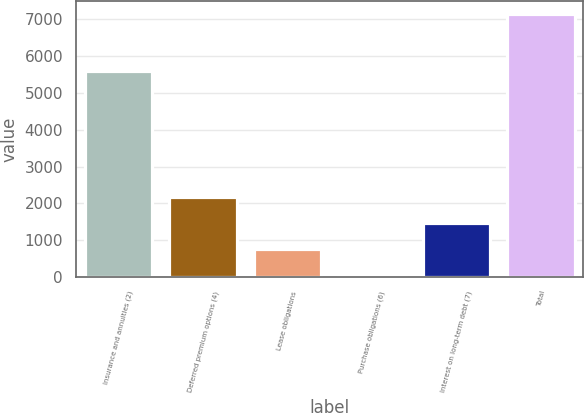<chart> <loc_0><loc_0><loc_500><loc_500><bar_chart><fcel>Insurance and annuities (2)<fcel>Deferred premium options (4)<fcel>Lease obligations<fcel>Purchase obligations (6)<fcel>Interest on long-term debt (7)<fcel>Total<nl><fcel>5589<fcel>2185.3<fcel>769.1<fcel>61<fcel>1477.2<fcel>7142<nl></chart> 